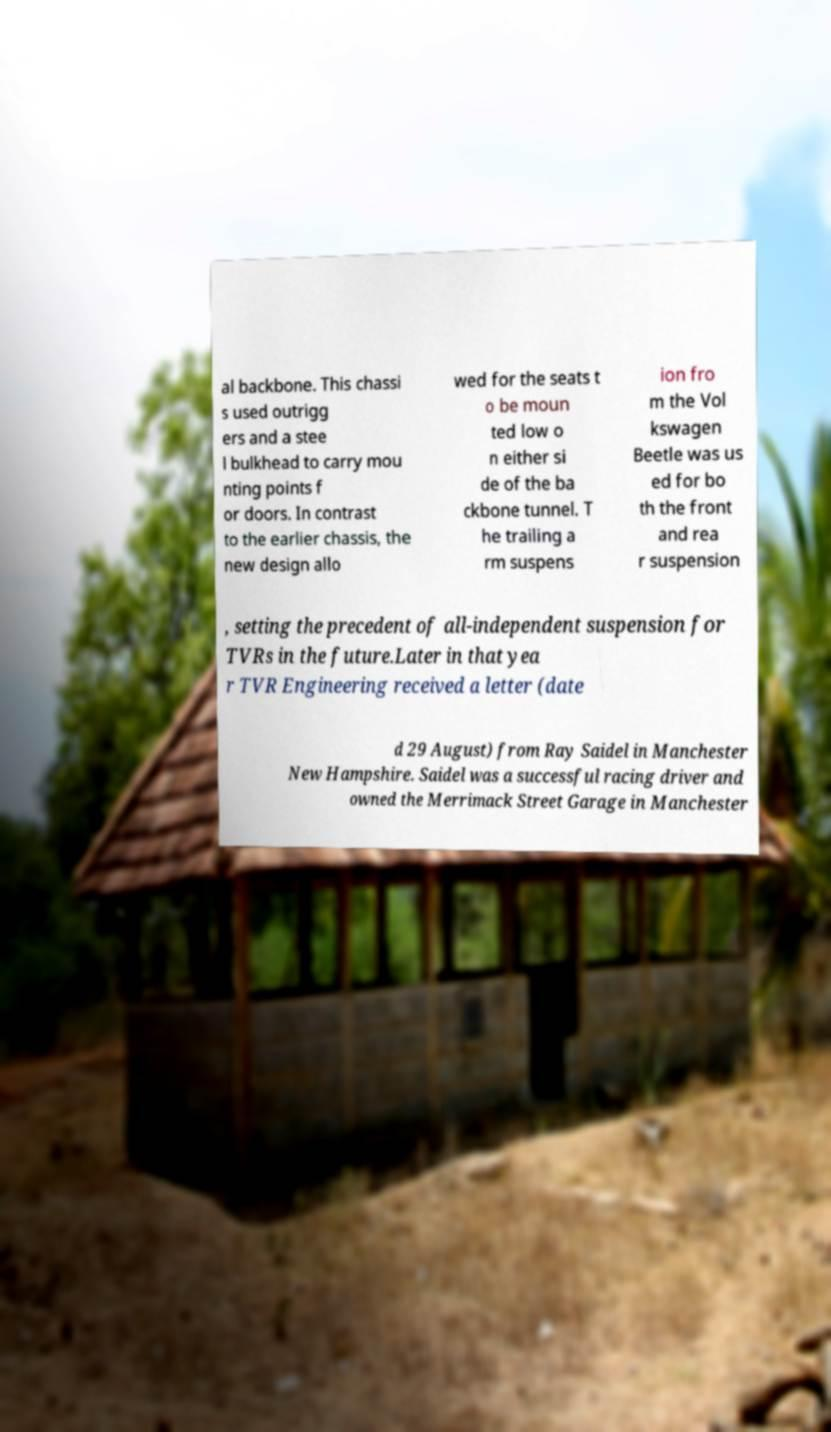Please read and relay the text visible in this image. What does it say? al backbone. This chassi s used outrigg ers and a stee l bulkhead to carry mou nting points f or doors. In contrast to the earlier chassis, the new design allo wed for the seats t o be moun ted low o n either si de of the ba ckbone tunnel. T he trailing a rm suspens ion fro m the Vol kswagen Beetle was us ed for bo th the front and rea r suspension , setting the precedent of all-independent suspension for TVRs in the future.Later in that yea r TVR Engineering received a letter (date d 29 August) from Ray Saidel in Manchester New Hampshire. Saidel was a successful racing driver and owned the Merrimack Street Garage in Manchester 